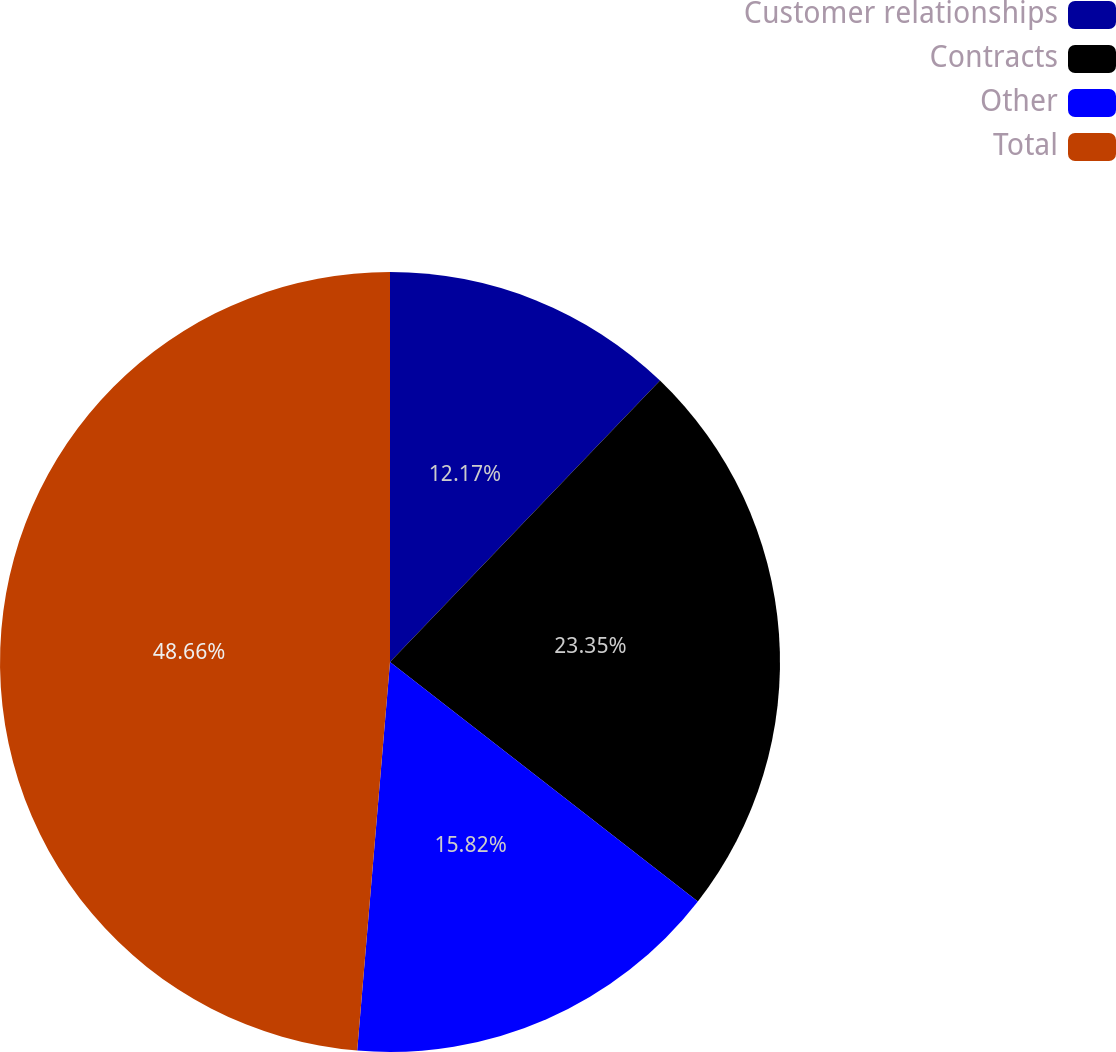Convert chart. <chart><loc_0><loc_0><loc_500><loc_500><pie_chart><fcel>Customer relationships<fcel>Contracts<fcel>Other<fcel>Total<nl><fcel>12.17%<fcel>23.35%<fcel>15.82%<fcel>48.66%<nl></chart> 